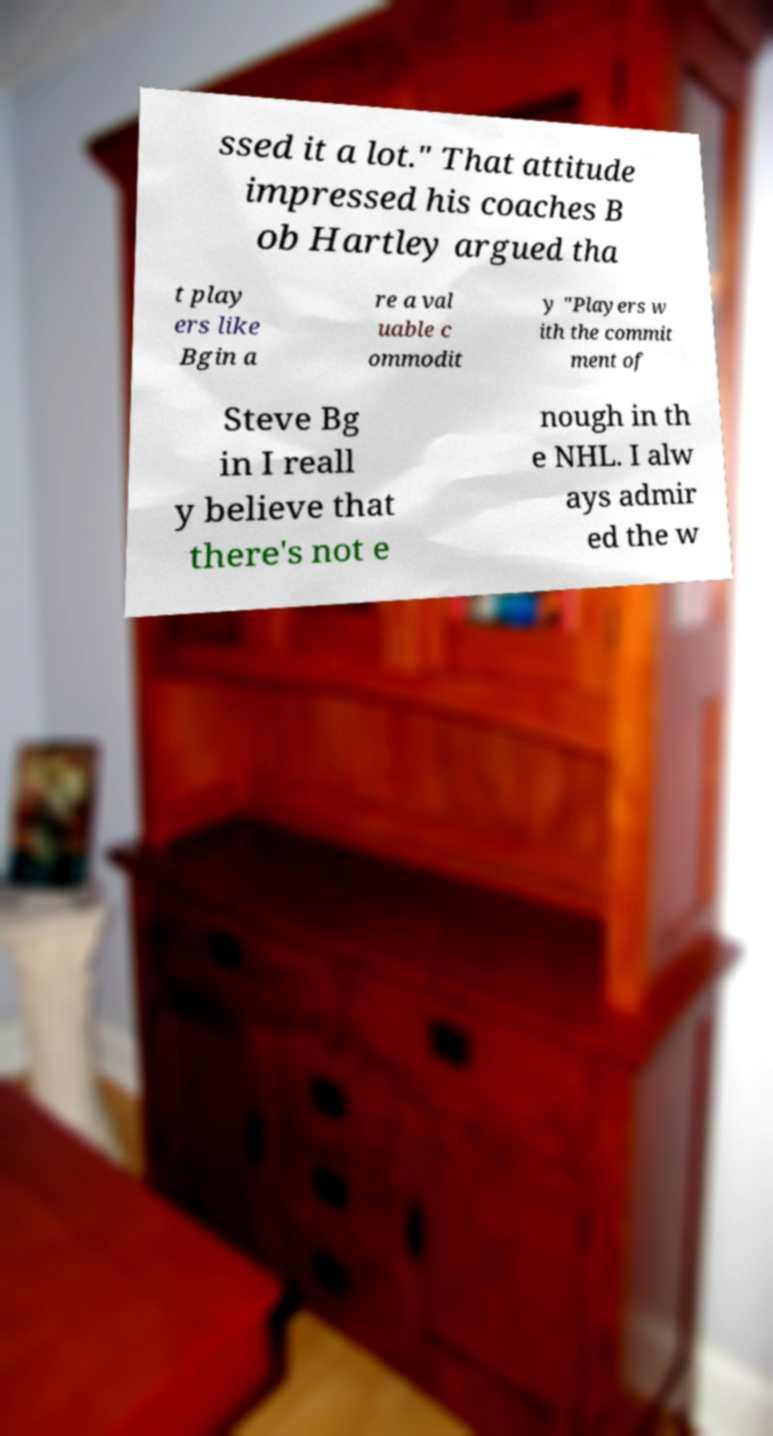For documentation purposes, I need the text within this image transcribed. Could you provide that? ssed it a lot." That attitude impressed his coaches B ob Hartley argued tha t play ers like Bgin a re a val uable c ommodit y "Players w ith the commit ment of Steve Bg in I reall y believe that there's not e nough in th e NHL. I alw ays admir ed the w 